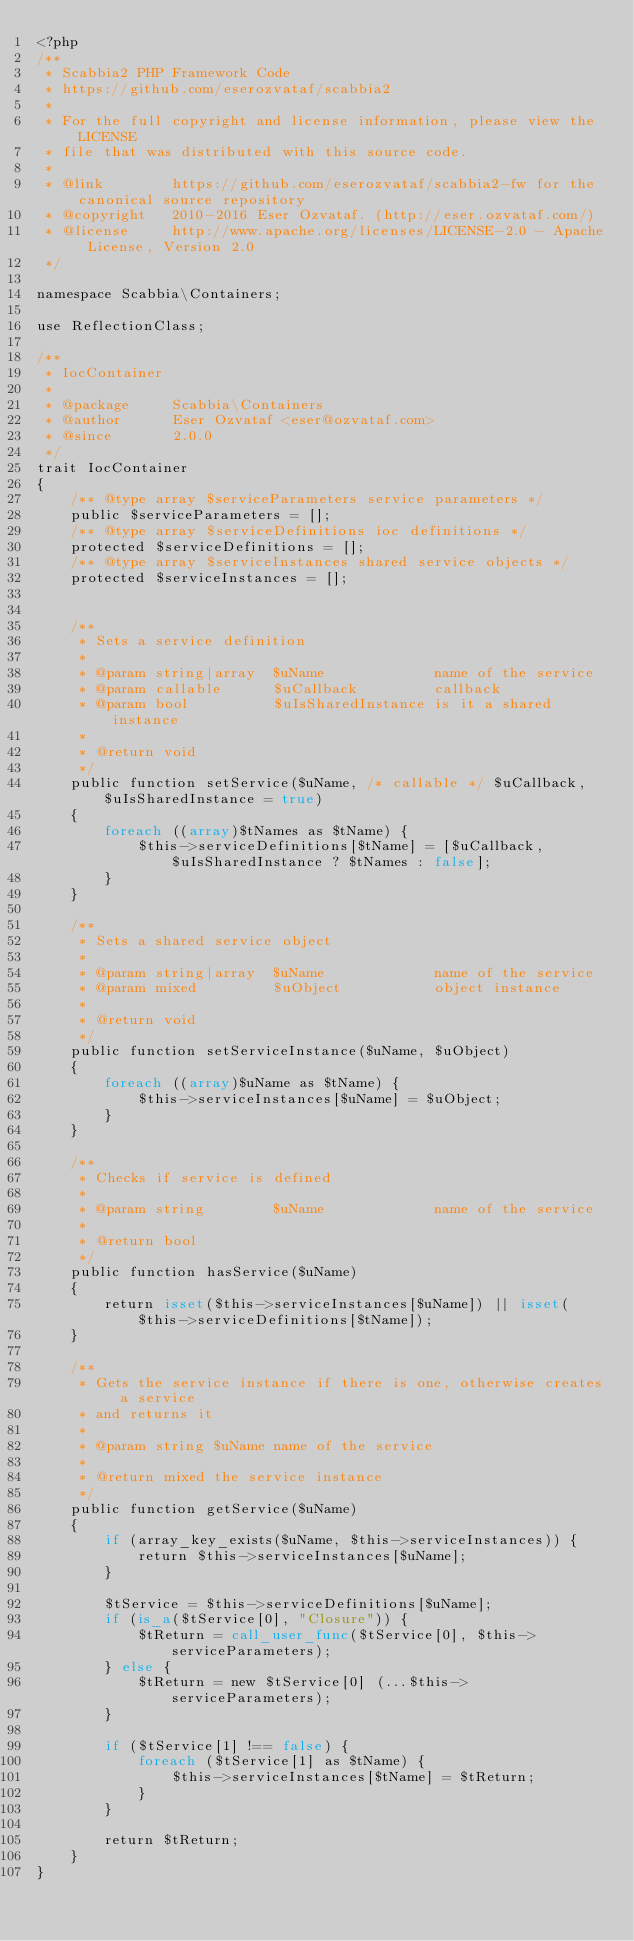<code> <loc_0><loc_0><loc_500><loc_500><_PHP_><?php
/**
 * Scabbia2 PHP Framework Code
 * https://github.com/eserozvataf/scabbia2
 *
 * For the full copyright and license information, please view the LICENSE
 * file that was distributed with this source code.
 *
 * @link        https://github.com/eserozvataf/scabbia2-fw for the canonical source repository
 * @copyright   2010-2016 Eser Ozvataf. (http://eser.ozvataf.com/)
 * @license     http://www.apache.org/licenses/LICENSE-2.0 - Apache License, Version 2.0
 */

namespace Scabbia\Containers;

use ReflectionClass;

/**
 * IocContainer
 *
 * @package     Scabbia\Containers
 * @author      Eser Ozvataf <eser@ozvataf.com>
 * @since       2.0.0
 */
trait IocContainer
{
    /** @type array $serviceParameters service parameters */
    public $serviceParameters = [];
    /** @type array $serviceDefinitions ioc definitions */
    protected $serviceDefinitions = [];
    /** @type array $serviceInstances shared service objects */
    protected $serviceInstances = [];


    /**
     * Sets a service definition
     *
     * @param string|array  $uName             name of the service
     * @param callable      $uCallback         callback
     * @param bool          $uIsSharedInstance is it a shared instance
     *
     * @return void
     */
    public function setService($uName, /* callable */ $uCallback, $uIsSharedInstance = true)
    {
        foreach ((array)$tNames as $tName) {
            $this->serviceDefinitions[$tName] = [$uCallback, $uIsSharedInstance ? $tNames : false];
        }
    }

    /**
     * Sets a shared service object
     *
     * @param string|array  $uName             name of the service
     * @param mixed         $uObject           object instance
     *
     * @return void
     */
    public function setServiceInstance($uName, $uObject)
    {
        foreach ((array)$uName as $tName) {
            $this->serviceInstances[$uName] = $uObject;
        }
    }

    /**
     * Checks if service is defined
     *
     * @param string        $uName             name of the service
     *
     * @return bool
     */
    public function hasService($uName)
    {
        return isset($this->serviceInstances[$uName]) || isset($this->serviceDefinitions[$tName]);
    }

    /**
     * Gets the service instance if there is one, otherwise creates a service
     * and returns it
     *
     * @param string $uName name of the service
     *
     * @return mixed the service instance
     */
    public function getService($uName)
    {
        if (array_key_exists($uName, $this->serviceInstances)) {
            return $this->serviceInstances[$uName];
        }

        $tService = $this->serviceDefinitions[$uName];
        if (is_a($tService[0], "Closure")) {
            $tReturn = call_user_func($tService[0], $this->serviceParameters);
        } else {
            $tReturn = new $tService[0] (...$this->serviceParameters);
        }

        if ($tService[1] !== false) {
            foreach ($tService[1] as $tName) {
                $this->serviceInstances[$tName] = $tReturn;
            }
        }

        return $tReturn;
    }
}
</code> 